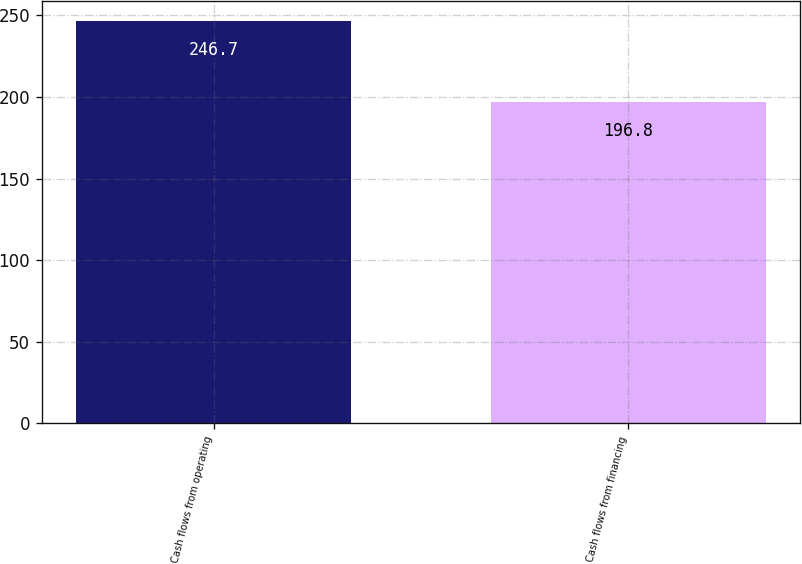<chart> <loc_0><loc_0><loc_500><loc_500><bar_chart><fcel>Cash flows from operating<fcel>Cash flows from financing<nl><fcel>246.7<fcel>196.8<nl></chart> 